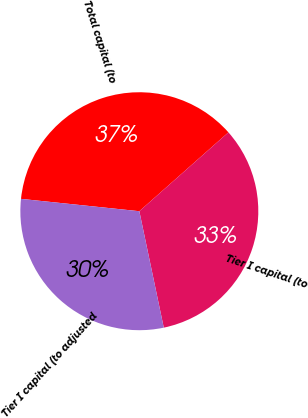Convert chart to OTSL. <chart><loc_0><loc_0><loc_500><loc_500><pie_chart><fcel>Total capital (to<fcel>Tier I capital (to<fcel>Tier I capital (to adjusted<nl><fcel>36.81%<fcel>33.24%<fcel>29.95%<nl></chart> 